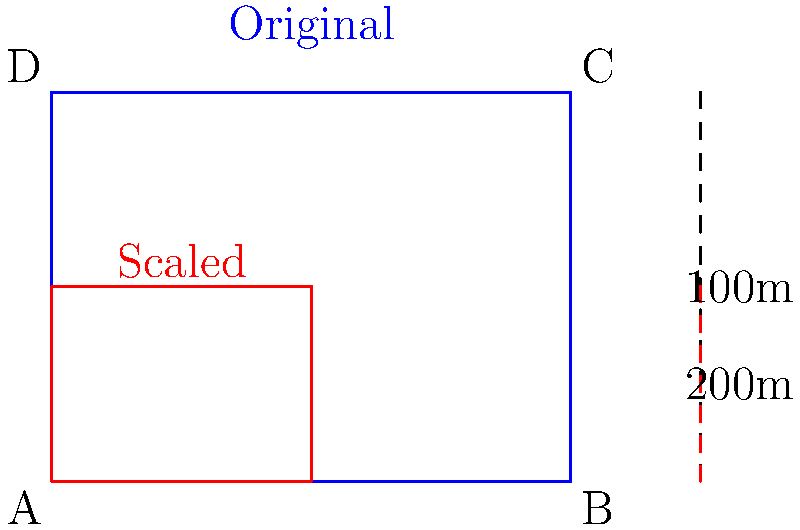A drone captures an image of a rectangular area on the ground from an altitude of 100m. The image covers an area of 4m × 3m. If the drone's altitude increases to 200m and it captures the same area, what scaling factor should be applied to the original image to represent the new perspective accurately? Assume the camera's field of view remains constant. To solve this problem, we need to understand the relationship between altitude and image scale:

1. The drone's altitude doubles from 100m to 200m.
2. The area captured on the ground remains the same (4m × 3m).
3. The camera's field of view is constant.

Given these conditions, we can deduce that:

4. As the altitude increases, the same ground area will appear smaller in the image.
5. The scaling factor will be inversely proportional to the change in altitude.

We can calculate the scaling factor as follows:

6. Scaling factor = Original altitude / New altitude
7. Scaling factor = 100m / 200m = 1/2 = 0.5

This means that each dimension of the original image should be multiplied by 0.5 to accurately represent the new perspective.

We can verify this:
8. Original image dimensions: 4m × 3m
9. Scaled image dimensions: 4m × 0.5 = 2m, 3m × 0.5 = 1.5m

The scaled image (2m × 1.5m) correctly represents the same ground area as viewed from the higher altitude.
Answer: 0.5 